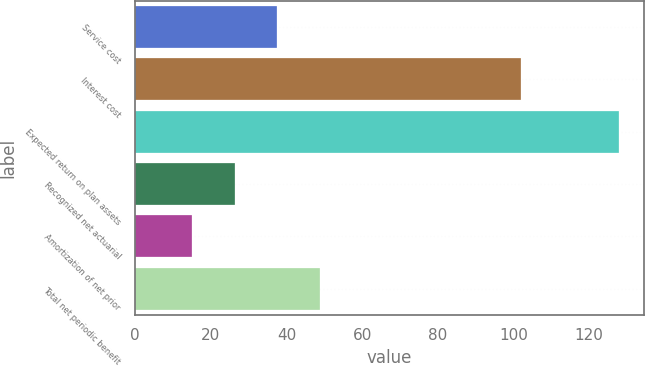Convert chart to OTSL. <chart><loc_0><loc_0><loc_500><loc_500><bar_chart><fcel>Service cost<fcel>Interest cost<fcel>Expected return on plan assets<fcel>Recognized net actuarial<fcel>Amortization of net prior<fcel>Total net periodic benefit<nl><fcel>37.6<fcel>102<fcel>128<fcel>26.3<fcel>15<fcel>48.9<nl></chart> 